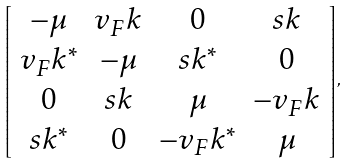Convert formula to latex. <formula><loc_0><loc_0><loc_500><loc_500>\left [ \begin{array} { c c c c } - \mu & v _ { F } k & 0 & s k \\ v _ { F } k ^ { * } & - \mu & s k ^ { * } & 0 \\ 0 & s k & \mu & - v _ { F } k \\ s k ^ { * } & 0 & - v _ { F } k ^ { * } & \mu \end{array} \right ] ,</formula> 